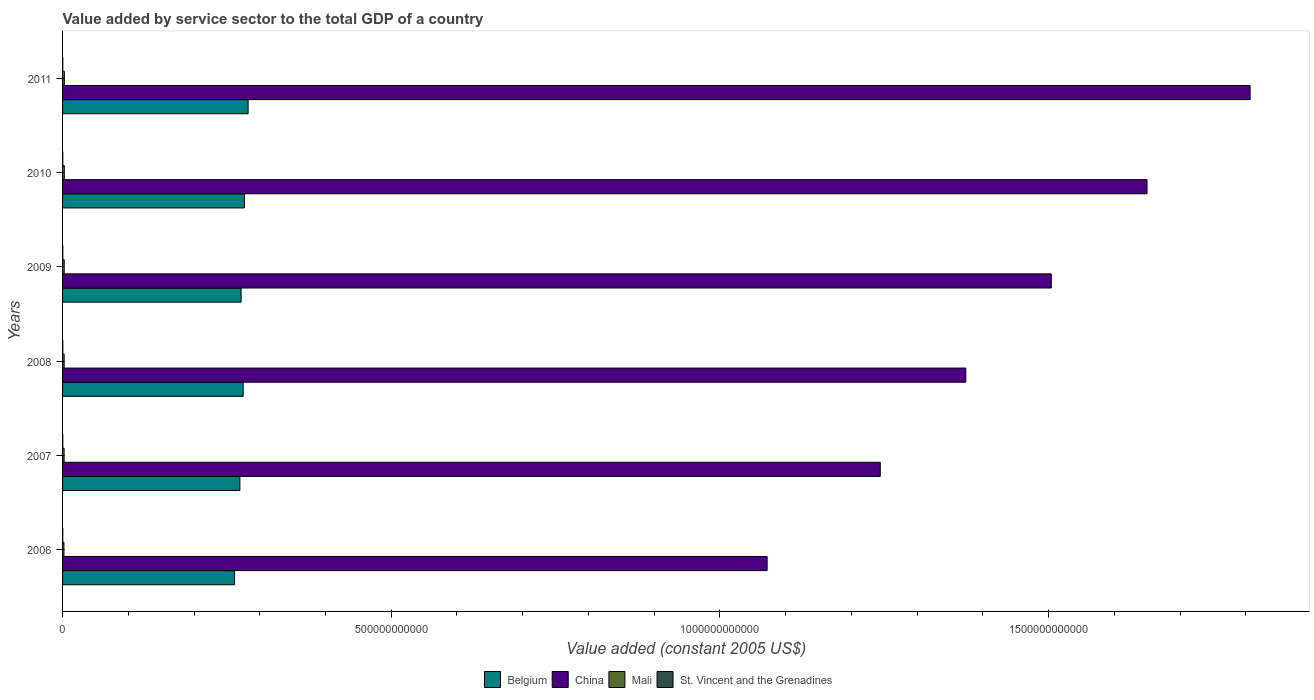How many bars are there on the 2nd tick from the top?
Keep it short and to the point. 4. What is the label of the 6th group of bars from the top?
Give a very brief answer. 2006. In how many cases, is the number of bars for a given year not equal to the number of legend labels?
Offer a terse response. 0. What is the value added by service sector in Mali in 2011?
Your answer should be compact. 2.73e+09. Across all years, what is the maximum value added by service sector in Belgium?
Ensure brevity in your answer.  2.82e+11. Across all years, what is the minimum value added by service sector in Mali?
Provide a succinct answer. 2.11e+09. In which year was the value added by service sector in St. Vincent and the Grenadines maximum?
Your response must be concise. 2008. In which year was the value added by service sector in Belgium minimum?
Your response must be concise. 2006. What is the total value added by service sector in St. Vincent and the Grenadines in the graph?
Your response must be concise. 2.31e+09. What is the difference between the value added by service sector in Mali in 2007 and that in 2011?
Provide a short and direct response. -3.99e+08. What is the difference between the value added by service sector in St. Vincent and the Grenadines in 2006 and the value added by service sector in Belgium in 2010?
Your response must be concise. -2.76e+11. What is the average value added by service sector in St. Vincent and the Grenadines per year?
Provide a succinct answer. 3.85e+08. In the year 2011, what is the difference between the value added by service sector in St. Vincent and the Grenadines and value added by service sector in Belgium?
Provide a short and direct response. -2.82e+11. In how many years, is the value added by service sector in Mali greater than 400000000000 US$?
Give a very brief answer. 0. What is the ratio of the value added by service sector in St. Vincent and the Grenadines in 2007 to that in 2011?
Your answer should be very brief. 1.01. Is the value added by service sector in China in 2007 less than that in 2009?
Keep it short and to the point. Yes. Is the difference between the value added by service sector in St. Vincent and the Grenadines in 2008 and 2010 greater than the difference between the value added by service sector in Belgium in 2008 and 2010?
Ensure brevity in your answer.  Yes. What is the difference between the highest and the second highest value added by service sector in Belgium?
Your answer should be very brief. 5.66e+09. What is the difference between the highest and the lowest value added by service sector in St. Vincent and the Grenadines?
Provide a succinct answer. 1.12e+07. In how many years, is the value added by service sector in China greater than the average value added by service sector in China taken over all years?
Make the answer very short. 3. Is the sum of the value added by service sector in Belgium in 2006 and 2011 greater than the maximum value added by service sector in St. Vincent and the Grenadines across all years?
Provide a short and direct response. Yes. Is it the case that in every year, the sum of the value added by service sector in China and value added by service sector in Mali is greater than the sum of value added by service sector in St. Vincent and the Grenadines and value added by service sector in Belgium?
Keep it short and to the point. Yes. What does the 4th bar from the top in 2010 represents?
Make the answer very short. Belgium. Is it the case that in every year, the sum of the value added by service sector in Mali and value added by service sector in Belgium is greater than the value added by service sector in China?
Ensure brevity in your answer.  No. Are all the bars in the graph horizontal?
Your response must be concise. Yes. What is the difference between two consecutive major ticks on the X-axis?
Your answer should be compact. 5.00e+11. Does the graph contain any zero values?
Your response must be concise. No. What is the title of the graph?
Your response must be concise. Value added by service sector to the total GDP of a country. What is the label or title of the X-axis?
Give a very brief answer. Value added (constant 2005 US$). What is the Value added (constant 2005 US$) of Belgium in 2006?
Your response must be concise. 2.62e+11. What is the Value added (constant 2005 US$) in China in 2006?
Provide a succinct answer. 1.07e+12. What is the Value added (constant 2005 US$) of Mali in 2006?
Your answer should be compact. 2.11e+09. What is the Value added (constant 2005 US$) of St. Vincent and the Grenadines in 2006?
Keep it short and to the point. 3.82e+08. What is the Value added (constant 2005 US$) in Belgium in 2007?
Offer a terse response. 2.70e+11. What is the Value added (constant 2005 US$) of China in 2007?
Provide a succinct answer. 1.24e+12. What is the Value added (constant 2005 US$) of Mali in 2007?
Give a very brief answer. 2.33e+09. What is the Value added (constant 2005 US$) in St. Vincent and the Grenadines in 2007?
Your answer should be very brief. 3.88e+08. What is the Value added (constant 2005 US$) in Belgium in 2008?
Give a very brief answer. 2.75e+11. What is the Value added (constant 2005 US$) of China in 2008?
Make the answer very short. 1.37e+12. What is the Value added (constant 2005 US$) of Mali in 2008?
Offer a terse response. 2.43e+09. What is the Value added (constant 2005 US$) of St. Vincent and the Grenadines in 2008?
Offer a terse response. 3.93e+08. What is the Value added (constant 2005 US$) in Belgium in 2009?
Give a very brief answer. 2.72e+11. What is the Value added (constant 2005 US$) of China in 2009?
Provide a succinct answer. 1.50e+12. What is the Value added (constant 2005 US$) of Mali in 2009?
Provide a short and direct response. 2.51e+09. What is the Value added (constant 2005 US$) in St. Vincent and the Grenadines in 2009?
Keep it short and to the point. 3.83e+08. What is the Value added (constant 2005 US$) in Belgium in 2010?
Your answer should be very brief. 2.77e+11. What is the Value added (constant 2005 US$) of China in 2010?
Offer a very short reply. 1.65e+12. What is the Value added (constant 2005 US$) in Mali in 2010?
Offer a terse response. 2.63e+09. What is the Value added (constant 2005 US$) in St. Vincent and the Grenadines in 2010?
Your answer should be very brief. 3.81e+08. What is the Value added (constant 2005 US$) in Belgium in 2011?
Give a very brief answer. 2.82e+11. What is the Value added (constant 2005 US$) in China in 2011?
Give a very brief answer. 1.81e+12. What is the Value added (constant 2005 US$) in Mali in 2011?
Provide a succinct answer. 2.73e+09. What is the Value added (constant 2005 US$) of St. Vincent and the Grenadines in 2011?
Ensure brevity in your answer.  3.84e+08. Across all years, what is the maximum Value added (constant 2005 US$) in Belgium?
Offer a terse response. 2.82e+11. Across all years, what is the maximum Value added (constant 2005 US$) of China?
Make the answer very short. 1.81e+12. Across all years, what is the maximum Value added (constant 2005 US$) in Mali?
Ensure brevity in your answer.  2.73e+09. Across all years, what is the maximum Value added (constant 2005 US$) of St. Vincent and the Grenadines?
Keep it short and to the point. 3.93e+08. Across all years, what is the minimum Value added (constant 2005 US$) of Belgium?
Provide a succinct answer. 2.62e+11. Across all years, what is the minimum Value added (constant 2005 US$) in China?
Offer a terse response. 1.07e+12. Across all years, what is the minimum Value added (constant 2005 US$) in Mali?
Keep it short and to the point. 2.11e+09. Across all years, what is the minimum Value added (constant 2005 US$) of St. Vincent and the Grenadines?
Make the answer very short. 3.81e+08. What is the total Value added (constant 2005 US$) of Belgium in the graph?
Offer a very short reply. 1.64e+12. What is the total Value added (constant 2005 US$) of China in the graph?
Give a very brief answer. 8.65e+12. What is the total Value added (constant 2005 US$) of Mali in the graph?
Offer a very short reply. 1.47e+1. What is the total Value added (constant 2005 US$) in St. Vincent and the Grenadines in the graph?
Your response must be concise. 2.31e+09. What is the difference between the Value added (constant 2005 US$) of Belgium in 2006 and that in 2007?
Offer a terse response. -8.08e+09. What is the difference between the Value added (constant 2005 US$) in China in 2006 and that in 2007?
Offer a very short reply. -1.72e+11. What is the difference between the Value added (constant 2005 US$) in Mali in 2006 and that in 2007?
Make the answer very short. -2.19e+08. What is the difference between the Value added (constant 2005 US$) of St. Vincent and the Grenadines in 2006 and that in 2007?
Offer a very short reply. -6.01e+06. What is the difference between the Value added (constant 2005 US$) of Belgium in 2006 and that in 2008?
Offer a terse response. -1.31e+1. What is the difference between the Value added (constant 2005 US$) in China in 2006 and that in 2008?
Make the answer very short. -3.02e+11. What is the difference between the Value added (constant 2005 US$) of Mali in 2006 and that in 2008?
Provide a short and direct response. -3.18e+08. What is the difference between the Value added (constant 2005 US$) in St. Vincent and the Grenadines in 2006 and that in 2008?
Your answer should be very brief. -1.02e+07. What is the difference between the Value added (constant 2005 US$) in Belgium in 2006 and that in 2009?
Your answer should be very brief. -9.95e+09. What is the difference between the Value added (constant 2005 US$) in China in 2006 and that in 2009?
Provide a succinct answer. -4.32e+11. What is the difference between the Value added (constant 2005 US$) in Mali in 2006 and that in 2009?
Your answer should be very brief. -4.04e+08. What is the difference between the Value added (constant 2005 US$) in St. Vincent and the Grenadines in 2006 and that in 2009?
Your response must be concise. -1.94e+05. What is the difference between the Value added (constant 2005 US$) of Belgium in 2006 and that in 2010?
Keep it short and to the point. -1.49e+1. What is the difference between the Value added (constant 2005 US$) of China in 2006 and that in 2010?
Give a very brief answer. -5.78e+11. What is the difference between the Value added (constant 2005 US$) in Mali in 2006 and that in 2010?
Offer a terse response. -5.18e+08. What is the difference between the Value added (constant 2005 US$) in St. Vincent and the Grenadines in 2006 and that in 2010?
Your answer should be very brief. 9.61e+05. What is the difference between the Value added (constant 2005 US$) of Belgium in 2006 and that in 2011?
Provide a short and direct response. -2.06e+1. What is the difference between the Value added (constant 2005 US$) in China in 2006 and that in 2011?
Offer a terse response. -7.35e+11. What is the difference between the Value added (constant 2005 US$) in Mali in 2006 and that in 2011?
Give a very brief answer. -6.18e+08. What is the difference between the Value added (constant 2005 US$) of St. Vincent and the Grenadines in 2006 and that in 2011?
Offer a very short reply. -1.56e+06. What is the difference between the Value added (constant 2005 US$) in Belgium in 2007 and that in 2008?
Your answer should be very brief. -5.02e+09. What is the difference between the Value added (constant 2005 US$) of China in 2007 and that in 2008?
Make the answer very short. -1.30e+11. What is the difference between the Value added (constant 2005 US$) in Mali in 2007 and that in 2008?
Provide a short and direct response. -9.94e+07. What is the difference between the Value added (constant 2005 US$) of St. Vincent and the Grenadines in 2007 and that in 2008?
Make the answer very short. -4.21e+06. What is the difference between the Value added (constant 2005 US$) in Belgium in 2007 and that in 2009?
Your response must be concise. -1.87e+09. What is the difference between the Value added (constant 2005 US$) in China in 2007 and that in 2009?
Give a very brief answer. -2.60e+11. What is the difference between the Value added (constant 2005 US$) in Mali in 2007 and that in 2009?
Your response must be concise. -1.85e+08. What is the difference between the Value added (constant 2005 US$) in St. Vincent and the Grenadines in 2007 and that in 2009?
Your answer should be compact. 5.81e+06. What is the difference between the Value added (constant 2005 US$) of Belgium in 2007 and that in 2010?
Provide a short and direct response. -6.84e+09. What is the difference between the Value added (constant 2005 US$) of China in 2007 and that in 2010?
Keep it short and to the point. -4.06e+11. What is the difference between the Value added (constant 2005 US$) in Mali in 2007 and that in 2010?
Provide a succinct answer. -2.99e+08. What is the difference between the Value added (constant 2005 US$) in St. Vincent and the Grenadines in 2007 and that in 2010?
Your response must be concise. 6.97e+06. What is the difference between the Value added (constant 2005 US$) in Belgium in 2007 and that in 2011?
Your answer should be compact. -1.25e+1. What is the difference between the Value added (constant 2005 US$) in China in 2007 and that in 2011?
Your answer should be compact. -5.63e+11. What is the difference between the Value added (constant 2005 US$) in Mali in 2007 and that in 2011?
Offer a very short reply. -3.99e+08. What is the difference between the Value added (constant 2005 US$) of St. Vincent and the Grenadines in 2007 and that in 2011?
Make the answer very short. 4.45e+06. What is the difference between the Value added (constant 2005 US$) in Belgium in 2008 and that in 2009?
Offer a very short reply. 3.15e+09. What is the difference between the Value added (constant 2005 US$) in China in 2008 and that in 2009?
Your response must be concise. -1.30e+11. What is the difference between the Value added (constant 2005 US$) in Mali in 2008 and that in 2009?
Ensure brevity in your answer.  -8.58e+07. What is the difference between the Value added (constant 2005 US$) in St. Vincent and the Grenadines in 2008 and that in 2009?
Your answer should be compact. 1.00e+07. What is the difference between the Value added (constant 2005 US$) in Belgium in 2008 and that in 2010?
Your answer should be compact. -1.81e+09. What is the difference between the Value added (constant 2005 US$) of China in 2008 and that in 2010?
Your answer should be compact. -2.76e+11. What is the difference between the Value added (constant 2005 US$) in Mali in 2008 and that in 2010?
Keep it short and to the point. -2.00e+08. What is the difference between the Value added (constant 2005 US$) of St. Vincent and the Grenadines in 2008 and that in 2010?
Provide a short and direct response. 1.12e+07. What is the difference between the Value added (constant 2005 US$) of Belgium in 2008 and that in 2011?
Provide a short and direct response. -7.47e+09. What is the difference between the Value added (constant 2005 US$) in China in 2008 and that in 2011?
Your answer should be compact. -4.33e+11. What is the difference between the Value added (constant 2005 US$) in Mali in 2008 and that in 2011?
Keep it short and to the point. -3.00e+08. What is the difference between the Value added (constant 2005 US$) of St. Vincent and the Grenadines in 2008 and that in 2011?
Your response must be concise. 8.65e+06. What is the difference between the Value added (constant 2005 US$) in Belgium in 2009 and that in 2010?
Your answer should be compact. -4.96e+09. What is the difference between the Value added (constant 2005 US$) of China in 2009 and that in 2010?
Offer a terse response. -1.46e+11. What is the difference between the Value added (constant 2005 US$) of Mali in 2009 and that in 2010?
Make the answer very short. -1.14e+08. What is the difference between the Value added (constant 2005 US$) in St. Vincent and the Grenadines in 2009 and that in 2010?
Your response must be concise. 1.16e+06. What is the difference between the Value added (constant 2005 US$) of Belgium in 2009 and that in 2011?
Keep it short and to the point. -1.06e+1. What is the difference between the Value added (constant 2005 US$) of China in 2009 and that in 2011?
Offer a very short reply. -3.02e+11. What is the difference between the Value added (constant 2005 US$) in Mali in 2009 and that in 2011?
Provide a succinct answer. -2.14e+08. What is the difference between the Value added (constant 2005 US$) of St. Vincent and the Grenadines in 2009 and that in 2011?
Provide a short and direct response. -1.37e+06. What is the difference between the Value added (constant 2005 US$) in Belgium in 2010 and that in 2011?
Offer a very short reply. -5.66e+09. What is the difference between the Value added (constant 2005 US$) in China in 2010 and that in 2011?
Offer a terse response. -1.57e+11. What is the difference between the Value added (constant 2005 US$) in Mali in 2010 and that in 2011?
Offer a terse response. -1.00e+08. What is the difference between the Value added (constant 2005 US$) in St. Vincent and the Grenadines in 2010 and that in 2011?
Your answer should be very brief. -2.52e+06. What is the difference between the Value added (constant 2005 US$) of Belgium in 2006 and the Value added (constant 2005 US$) of China in 2007?
Your answer should be compact. -9.82e+11. What is the difference between the Value added (constant 2005 US$) in Belgium in 2006 and the Value added (constant 2005 US$) in Mali in 2007?
Keep it short and to the point. 2.59e+11. What is the difference between the Value added (constant 2005 US$) in Belgium in 2006 and the Value added (constant 2005 US$) in St. Vincent and the Grenadines in 2007?
Keep it short and to the point. 2.61e+11. What is the difference between the Value added (constant 2005 US$) in China in 2006 and the Value added (constant 2005 US$) in Mali in 2007?
Give a very brief answer. 1.07e+12. What is the difference between the Value added (constant 2005 US$) in China in 2006 and the Value added (constant 2005 US$) in St. Vincent and the Grenadines in 2007?
Keep it short and to the point. 1.07e+12. What is the difference between the Value added (constant 2005 US$) of Mali in 2006 and the Value added (constant 2005 US$) of St. Vincent and the Grenadines in 2007?
Offer a terse response. 1.72e+09. What is the difference between the Value added (constant 2005 US$) of Belgium in 2006 and the Value added (constant 2005 US$) of China in 2008?
Give a very brief answer. -1.11e+12. What is the difference between the Value added (constant 2005 US$) of Belgium in 2006 and the Value added (constant 2005 US$) of Mali in 2008?
Your answer should be very brief. 2.59e+11. What is the difference between the Value added (constant 2005 US$) in Belgium in 2006 and the Value added (constant 2005 US$) in St. Vincent and the Grenadines in 2008?
Your answer should be compact. 2.61e+11. What is the difference between the Value added (constant 2005 US$) in China in 2006 and the Value added (constant 2005 US$) in Mali in 2008?
Provide a succinct answer. 1.07e+12. What is the difference between the Value added (constant 2005 US$) in China in 2006 and the Value added (constant 2005 US$) in St. Vincent and the Grenadines in 2008?
Keep it short and to the point. 1.07e+12. What is the difference between the Value added (constant 2005 US$) of Mali in 2006 and the Value added (constant 2005 US$) of St. Vincent and the Grenadines in 2008?
Provide a succinct answer. 1.72e+09. What is the difference between the Value added (constant 2005 US$) of Belgium in 2006 and the Value added (constant 2005 US$) of China in 2009?
Ensure brevity in your answer.  -1.24e+12. What is the difference between the Value added (constant 2005 US$) of Belgium in 2006 and the Value added (constant 2005 US$) of Mali in 2009?
Provide a succinct answer. 2.59e+11. What is the difference between the Value added (constant 2005 US$) in Belgium in 2006 and the Value added (constant 2005 US$) in St. Vincent and the Grenadines in 2009?
Your answer should be compact. 2.61e+11. What is the difference between the Value added (constant 2005 US$) in China in 2006 and the Value added (constant 2005 US$) in Mali in 2009?
Your answer should be compact. 1.07e+12. What is the difference between the Value added (constant 2005 US$) in China in 2006 and the Value added (constant 2005 US$) in St. Vincent and the Grenadines in 2009?
Your response must be concise. 1.07e+12. What is the difference between the Value added (constant 2005 US$) of Mali in 2006 and the Value added (constant 2005 US$) of St. Vincent and the Grenadines in 2009?
Give a very brief answer. 1.73e+09. What is the difference between the Value added (constant 2005 US$) in Belgium in 2006 and the Value added (constant 2005 US$) in China in 2010?
Keep it short and to the point. -1.39e+12. What is the difference between the Value added (constant 2005 US$) in Belgium in 2006 and the Value added (constant 2005 US$) in Mali in 2010?
Offer a very short reply. 2.59e+11. What is the difference between the Value added (constant 2005 US$) of Belgium in 2006 and the Value added (constant 2005 US$) of St. Vincent and the Grenadines in 2010?
Ensure brevity in your answer.  2.61e+11. What is the difference between the Value added (constant 2005 US$) of China in 2006 and the Value added (constant 2005 US$) of Mali in 2010?
Provide a succinct answer. 1.07e+12. What is the difference between the Value added (constant 2005 US$) of China in 2006 and the Value added (constant 2005 US$) of St. Vincent and the Grenadines in 2010?
Provide a succinct answer. 1.07e+12. What is the difference between the Value added (constant 2005 US$) of Mali in 2006 and the Value added (constant 2005 US$) of St. Vincent and the Grenadines in 2010?
Your response must be concise. 1.73e+09. What is the difference between the Value added (constant 2005 US$) of Belgium in 2006 and the Value added (constant 2005 US$) of China in 2011?
Give a very brief answer. -1.54e+12. What is the difference between the Value added (constant 2005 US$) of Belgium in 2006 and the Value added (constant 2005 US$) of Mali in 2011?
Make the answer very short. 2.59e+11. What is the difference between the Value added (constant 2005 US$) in Belgium in 2006 and the Value added (constant 2005 US$) in St. Vincent and the Grenadines in 2011?
Offer a terse response. 2.61e+11. What is the difference between the Value added (constant 2005 US$) of China in 2006 and the Value added (constant 2005 US$) of Mali in 2011?
Provide a short and direct response. 1.07e+12. What is the difference between the Value added (constant 2005 US$) of China in 2006 and the Value added (constant 2005 US$) of St. Vincent and the Grenadines in 2011?
Offer a very short reply. 1.07e+12. What is the difference between the Value added (constant 2005 US$) in Mali in 2006 and the Value added (constant 2005 US$) in St. Vincent and the Grenadines in 2011?
Your response must be concise. 1.72e+09. What is the difference between the Value added (constant 2005 US$) of Belgium in 2007 and the Value added (constant 2005 US$) of China in 2008?
Offer a very short reply. -1.10e+12. What is the difference between the Value added (constant 2005 US$) in Belgium in 2007 and the Value added (constant 2005 US$) in Mali in 2008?
Your answer should be compact. 2.67e+11. What is the difference between the Value added (constant 2005 US$) in Belgium in 2007 and the Value added (constant 2005 US$) in St. Vincent and the Grenadines in 2008?
Ensure brevity in your answer.  2.69e+11. What is the difference between the Value added (constant 2005 US$) in China in 2007 and the Value added (constant 2005 US$) in Mali in 2008?
Your response must be concise. 1.24e+12. What is the difference between the Value added (constant 2005 US$) in China in 2007 and the Value added (constant 2005 US$) in St. Vincent and the Grenadines in 2008?
Ensure brevity in your answer.  1.24e+12. What is the difference between the Value added (constant 2005 US$) of Mali in 2007 and the Value added (constant 2005 US$) of St. Vincent and the Grenadines in 2008?
Provide a succinct answer. 1.93e+09. What is the difference between the Value added (constant 2005 US$) in Belgium in 2007 and the Value added (constant 2005 US$) in China in 2009?
Your response must be concise. -1.23e+12. What is the difference between the Value added (constant 2005 US$) of Belgium in 2007 and the Value added (constant 2005 US$) of Mali in 2009?
Your answer should be compact. 2.67e+11. What is the difference between the Value added (constant 2005 US$) in Belgium in 2007 and the Value added (constant 2005 US$) in St. Vincent and the Grenadines in 2009?
Your response must be concise. 2.69e+11. What is the difference between the Value added (constant 2005 US$) in China in 2007 and the Value added (constant 2005 US$) in Mali in 2009?
Make the answer very short. 1.24e+12. What is the difference between the Value added (constant 2005 US$) in China in 2007 and the Value added (constant 2005 US$) in St. Vincent and the Grenadines in 2009?
Your answer should be compact. 1.24e+12. What is the difference between the Value added (constant 2005 US$) in Mali in 2007 and the Value added (constant 2005 US$) in St. Vincent and the Grenadines in 2009?
Provide a succinct answer. 1.94e+09. What is the difference between the Value added (constant 2005 US$) of Belgium in 2007 and the Value added (constant 2005 US$) of China in 2010?
Your response must be concise. -1.38e+12. What is the difference between the Value added (constant 2005 US$) in Belgium in 2007 and the Value added (constant 2005 US$) in Mali in 2010?
Provide a succinct answer. 2.67e+11. What is the difference between the Value added (constant 2005 US$) in Belgium in 2007 and the Value added (constant 2005 US$) in St. Vincent and the Grenadines in 2010?
Give a very brief answer. 2.69e+11. What is the difference between the Value added (constant 2005 US$) in China in 2007 and the Value added (constant 2005 US$) in Mali in 2010?
Keep it short and to the point. 1.24e+12. What is the difference between the Value added (constant 2005 US$) of China in 2007 and the Value added (constant 2005 US$) of St. Vincent and the Grenadines in 2010?
Your answer should be very brief. 1.24e+12. What is the difference between the Value added (constant 2005 US$) in Mali in 2007 and the Value added (constant 2005 US$) in St. Vincent and the Grenadines in 2010?
Provide a succinct answer. 1.95e+09. What is the difference between the Value added (constant 2005 US$) of Belgium in 2007 and the Value added (constant 2005 US$) of China in 2011?
Your answer should be very brief. -1.54e+12. What is the difference between the Value added (constant 2005 US$) in Belgium in 2007 and the Value added (constant 2005 US$) in Mali in 2011?
Offer a terse response. 2.67e+11. What is the difference between the Value added (constant 2005 US$) in Belgium in 2007 and the Value added (constant 2005 US$) in St. Vincent and the Grenadines in 2011?
Ensure brevity in your answer.  2.69e+11. What is the difference between the Value added (constant 2005 US$) of China in 2007 and the Value added (constant 2005 US$) of Mali in 2011?
Your answer should be very brief. 1.24e+12. What is the difference between the Value added (constant 2005 US$) in China in 2007 and the Value added (constant 2005 US$) in St. Vincent and the Grenadines in 2011?
Your response must be concise. 1.24e+12. What is the difference between the Value added (constant 2005 US$) of Mali in 2007 and the Value added (constant 2005 US$) of St. Vincent and the Grenadines in 2011?
Your answer should be very brief. 1.94e+09. What is the difference between the Value added (constant 2005 US$) in Belgium in 2008 and the Value added (constant 2005 US$) in China in 2009?
Your answer should be compact. -1.23e+12. What is the difference between the Value added (constant 2005 US$) in Belgium in 2008 and the Value added (constant 2005 US$) in Mali in 2009?
Your answer should be very brief. 2.72e+11. What is the difference between the Value added (constant 2005 US$) of Belgium in 2008 and the Value added (constant 2005 US$) of St. Vincent and the Grenadines in 2009?
Your response must be concise. 2.74e+11. What is the difference between the Value added (constant 2005 US$) in China in 2008 and the Value added (constant 2005 US$) in Mali in 2009?
Offer a terse response. 1.37e+12. What is the difference between the Value added (constant 2005 US$) of China in 2008 and the Value added (constant 2005 US$) of St. Vincent and the Grenadines in 2009?
Provide a short and direct response. 1.37e+12. What is the difference between the Value added (constant 2005 US$) in Mali in 2008 and the Value added (constant 2005 US$) in St. Vincent and the Grenadines in 2009?
Your answer should be compact. 2.04e+09. What is the difference between the Value added (constant 2005 US$) of Belgium in 2008 and the Value added (constant 2005 US$) of China in 2010?
Keep it short and to the point. -1.38e+12. What is the difference between the Value added (constant 2005 US$) in Belgium in 2008 and the Value added (constant 2005 US$) in Mali in 2010?
Give a very brief answer. 2.72e+11. What is the difference between the Value added (constant 2005 US$) of Belgium in 2008 and the Value added (constant 2005 US$) of St. Vincent and the Grenadines in 2010?
Provide a short and direct response. 2.74e+11. What is the difference between the Value added (constant 2005 US$) in China in 2008 and the Value added (constant 2005 US$) in Mali in 2010?
Offer a very short reply. 1.37e+12. What is the difference between the Value added (constant 2005 US$) in China in 2008 and the Value added (constant 2005 US$) in St. Vincent and the Grenadines in 2010?
Your answer should be compact. 1.37e+12. What is the difference between the Value added (constant 2005 US$) of Mali in 2008 and the Value added (constant 2005 US$) of St. Vincent and the Grenadines in 2010?
Your response must be concise. 2.04e+09. What is the difference between the Value added (constant 2005 US$) of Belgium in 2008 and the Value added (constant 2005 US$) of China in 2011?
Offer a terse response. -1.53e+12. What is the difference between the Value added (constant 2005 US$) of Belgium in 2008 and the Value added (constant 2005 US$) of Mali in 2011?
Your response must be concise. 2.72e+11. What is the difference between the Value added (constant 2005 US$) of Belgium in 2008 and the Value added (constant 2005 US$) of St. Vincent and the Grenadines in 2011?
Provide a succinct answer. 2.74e+11. What is the difference between the Value added (constant 2005 US$) of China in 2008 and the Value added (constant 2005 US$) of Mali in 2011?
Your response must be concise. 1.37e+12. What is the difference between the Value added (constant 2005 US$) of China in 2008 and the Value added (constant 2005 US$) of St. Vincent and the Grenadines in 2011?
Keep it short and to the point. 1.37e+12. What is the difference between the Value added (constant 2005 US$) in Mali in 2008 and the Value added (constant 2005 US$) in St. Vincent and the Grenadines in 2011?
Your answer should be compact. 2.04e+09. What is the difference between the Value added (constant 2005 US$) of Belgium in 2009 and the Value added (constant 2005 US$) of China in 2010?
Make the answer very short. -1.38e+12. What is the difference between the Value added (constant 2005 US$) of Belgium in 2009 and the Value added (constant 2005 US$) of Mali in 2010?
Keep it short and to the point. 2.69e+11. What is the difference between the Value added (constant 2005 US$) in Belgium in 2009 and the Value added (constant 2005 US$) in St. Vincent and the Grenadines in 2010?
Provide a succinct answer. 2.71e+11. What is the difference between the Value added (constant 2005 US$) in China in 2009 and the Value added (constant 2005 US$) in Mali in 2010?
Ensure brevity in your answer.  1.50e+12. What is the difference between the Value added (constant 2005 US$) in China in 2009 and the Value added (constant 2005 US$) in St. Vincent and the Grenadines in 2010?
Offer a very short reply. 1.50e+12. What is the difference between the Value added (constant 2005 US$) of Mali in 2009 and the Value added (constant 2005 US$) of St. Vincent and the Grenadines in 2010?
Your answer should be very brief. 2.13e+09. What is the difference between the Value added (constant 2005 US$) of Belgium in 2009 and the Value added (constant 2005 US$) of China in 2011?
Provide a succinct answer. -1.54e+12. What is the difference between the Value added (constant 2005 US$) of Belgium in 2009 and the Value added (constant 2005 US$) of Mali in 2011?
Offer a terse response. 2.69e+11. What is the difference between the Value added (constant 2005 US$) in Belgium in 2009 and the Value added (constant 2005 US$) in St. Vincent and the Grenadines in 2011?
Ensure brevity in your answer.  2.71e+11. What is the difference between the Value added (constant 2005 US$) of China in 2009 and the Value added (constant 2005 US$) of Mali in 2011?
Keep it short and to the point. 1.50e+12. What is the difference between the Value added (constant 2005 US$) of China in 2009 and the Value added (constant 2005 US$) of St. Vincent and the Grenadines in 2011?
Offer a very short reply. 1.50e+12. What is the difference between the Value added (constant 2005 US$) of Mali in 2009 and the Value added (constant 2005 US$) of St. Vincent and the Grenadines in 2011?
Offer a terse response. 2.13e+09. What is the difference between the Value added (constant 2005 US$) in Belgium in 2010 and the Value added (constant 2005 US$) in China in 2011?
Offer a very short reply. -1.53e+12. What is the difference between the Value added (constant 2005 US$) of Belgium in 2010 and the Value added (constant 2005 US$) of Mali in 2011?
Provide a succinct answer. 2.74e+11. What is the difference between the Value added (constant 2005 US$) of Belgium in 2010 and the Value added (constant 2005 US$) of St. Vincent and the Grenadines in 2011?
Provide a short and direct response. 2.76e+11. What is the difference between the Value added (constant 2005 US$) of China in 2010 and the Value added (constant 2005 US$) of Mali in 2011?
Ensure brevity in your answer.  1.65e+12. What is the difference between the Value added (constant 2005 US$) of China in 2010 and the Value added (constant 2005 US$) of St. Vincent and the Grenadines in 2011?
Provide a short and direct response. 1.65e+12. What is the difference between the Value added (constant 2005 US$) of Mali in 2010 and the Value added (constant 2005 US$) of St. Vincent and the Grenadines in 2011?
Your response must be concise. 2.24e+09. What is the average Value added (constant 2005 US$) in Belgium per year?
Provide a short and direct response. 2.73e+11. What is the average Value added (constant 2005 US$) of China per year?
Ensure brevity in your answer.  1.44e+12. What is the average Value added (constant 2005 US$) in Mali per year?
Your answer should be compact. 2.45e+09. What is the average Value added (constant 2005 US$) of St. Vincent and the Grenadines per year?
Offer a very short reply. 3.85e+08. In the year 2006, what is the difference between the Value added (constant 2005 US$) of Belgium and Value added (constant 2005 US$) of China?
Your answer should be compact. -8.10e+11. In the year 2006, what is the difference between the Value added (constant 2005 US$) of Belgium and Value added (constant 2005 US$) of Mali?
Offer a terse response. 2.60e+11. In the year 2006, what is the difference between the Value added (constant 2005 US$) of Belgium and Value added (constant 2005 US$) of St. Vincent and the Grenadines?
Your answer should be compact. 2.61e+11. In the year 2006, what is the difference between the Value added (constant 2005 US$) of China and Value added (constant 2005 US$) of Mali?
Your answer should be compact. 1.07e+12. In the year 2006, what is the difference between the Value added (constant 2005 US$) in China and Value added (constant 2005 US$) in St. Vincent and the Grenadines?
Offer a terse response. 1.07e+12. In the year 2006, what is the difference between the Value added (constant 2005 US$) of Mali and Value added (constant 2005 US$) of St. Vincent and the Grenadines?
Give a very brief answer. 1.73e+09. In the year 2007, what is the difference between the Value added (constant 2005 US$) in Belgium and Value added (constant 2005 US$) in China?
Ensure brevity in your answer.  -9.74e+11. In the year 2007, what is the difference between the Value added (constant 2005 US$) in Belgium and Value added (constant 2005 US$) in Mali?
Offer a very short reply. 2.67e+11. In the year 2007, what is the difference between the Value added (constant 2005 US$) of Belgium and Value added (constant 2005 US$) of St. Vincent and the Grenadines?
Give a very brief answer. 2.69e+11. In the year 2007, what is the difference between the Value added (constant 2005 US$) in China and Value added (constant 2005 US$) in Mali?
Provide a succinct answer. 1.24e+12. In the year 2007, what is the difference between the Value added (constant 2005 US$) in China and Value added (constant 2005 US$) in St. Vincent and the Grenadines?
Offer a terse response. 1.24e+12. In the year 2007, what is the difference between the Value added (constant 2005 US$) of Mali and Value added (constant 2005 US$) of St. Vincent and the Grenadines?
Provide a short and direct response. 1.94e+09. In the year 2008, what is the difference between the Value added (constant 2005 US$) of Belgium and Value added (constant 2005 US$) of China?
Make the answer very short. -1.10e+12. In the year 2008, what is the difference between the Value added (constant 2005 US$) in Belgium and Value added (constant 2005 US$) in Mali?
Ensure brevity in your answer.  2.72e+11. In the year 2008, what is the difference between the Value added (constant 2005 US$) of Belgium and Value added (constant 2005 US$) of St. Vincent and the Grenadines?
Your response must be concise. 2.74e+11. In the year 2008, what is the difference between the Value added (constant 2005 US$) in China and Value added (constant 2005 US$) in Mali?
Offer a terse response. 1.37e+12. In the year 2008, what is the difference between the Value added (constant 2005 US$) in China and Value added (constant 2005 US$) in St. Vincent and the Grenadines?
Make the answer very short. 1.37e+12. In the year 2008, what is the difference between the Value added (constant 2005 US$) in Mali and Value added (constant 2005 US$) in St. Vincent and the Grenadines?
Your response must be concise. 2.03e+09. In the year 2009, what is the difference between the Value added (constant 2005 US$) in Belgium and Value added (constant 2005 US$) in China?
Your answer should be very brief. -1.23e+12. In the year 2009, what is the difference between the Value added (constant 2005 US$) in Belgium and Value added (constant 2005 US$) in Mali?
Provide a short and direct response. 2.69e+11. In the year 2009, what is the difference between the Value added (constant 2005 US$) in Belgium and Value added (constant 2005 US$) in St. Vincent and the Grenadines?
Keep it short and to the point. 2.71e+11. In the year 2009, what is the difference between the Value added (constant 2005 US$) of China and Value added (constant 2005 US$) of Mali?
Provide a short and direct response. 1.50e+12. In the year 2009, what is the difference between the Value added (constant 2005 US$) of China and Value added (constant 2005 US$) of St. Vincent and the Grenadines?
Your answer should be very brief. 1.50e+12. In the year 2009, what is the difference between the Value added (constant 2005 US$) in Mali and Value added (constant 2005 US$) in St. Vincent and the Grenadines?
Provide a succinct answer. 2.13e+09. In the year 2010, what is the difference between the Value added (constant 2005 US$) in Belgium and Value added (constant 2005 US$) in China?
Offer a very short reply. -1.37e+12. In the year 2010, what is the difference between the Value added (constant 2005 US$) in Belgium and Value added (constant 2005 US$) in Mali?
Your response must be concise. 2.74e+11. In the year 2010, what is the difference between the Value added (constant 2005 US$) of Belgium and Value added (constant 2005 US$) of St. Vincent and the Grenadines?
Keep it short and to the point. 2.76e+11. In the year 2010, what is the difference between the Value added (constant 2005 US$) of China and Value added (constant 2005 US$) of Mali?
Provide a succinct answer. 1.65e+12. In the year 2010, what is the difference between the Value added (constant 2005 US$) in China and Value added (constant 2005 US$) in St. Vincent and the Grenadines?
Provide a short and direct response. 1.65e+12. In the year 2010, what is the difference between the Value added (constant 2005 US$) of Mali and Value added (constant 2005 US$) of St. Vincent and the Grenadines?
Provide a short and direct response. 2.24e+09. In the year 2011, what is the difference between the Value added (constant 2005 US$) in Belgium and Value added (constant 2005 US$) in China?
Provide a short and direct response. -1.52e+12. In the year 2011, what is the difference between the Value added (constant 2005 US$) of Belgium and Value added (constant 2005 US$) of Mali?
Keep it short and to the point. 2.80e+11. In the year 2011, what is the difference between the Value added (constant 2005 US$) of Belgium and Value added (constant 2005 US$) of St. Vincent and the Grenadines?
Your response must be concise. 2.82e+11. In the year 2011, what is the difference between the Value added (constant 2005 US$) in China and Value added (constant 2005 US$) in Mali?
Ensure brevity in your answer.  1.80e+12. In the year 2011, what is the difference between the Value added (constant 2005 US$) in China and Value added (constant 2005 US$) in St. Vincent and the Grenadines?
Ensure brevity in your answer.  1.81e+12. In the year 2011, what is the difference between the Value added (constant 2005 US$) of Mali and Value added (constant 2005 US$) of St. Vincent and the Grenadines?
Provide a succinct answer. 2.34e+09. What is the ratio of the Value added (constant 2005 US$) in Belgium in 2006 to that in 2007?
Give a very brief answer. 0.97. What is the ratio of the Value added (constant 2005 US$) of China in 2006 to that in 2007?
Give a very brief answer. 0.86. What is the ratio of the Value added (constant 2005 US$) of Mali in 2006 to that in 2007?
Provide a succinct answer. 0.91. What is the ratio of the Value added (constant 2005 US$) of St. Vincent and the Grenadines in 2006 to that in 2007?
Ensure brevity in your answer.  0.98. What is the ratio of the Value added (constant 2005 US$) of Belgium in 2006 to that in 2008?
Provide a succinct answer. 0.95. What is the ratio of the Value added (constant 2005 US$) of China in 2006 to that in 2008?
Ensure brevity in your answer.  0.78. What is the ratio of the Value added (constant 2005 US$) of Mali in 2006 to that in 2008?
Keep it short and to the point. 0.87. What is the ratio of the Value added (constant 2005 US$) in Belgium in 2006 to that in 2009?
Offer a terse response. 0.96. What is the ratio of the Value added (constant 2005 US$) in China in 2006 to that in 2009?
Offer a very short reply. 0.71. What is the ratio of the Value added (constant 2005 US$) in Mali in 2006 to that in 2009?
Keep it short and to the point. 0.84. What is the ratio of the Value added (constant 2005 US$) in Belgium in 2006 to that in 2010?
Give a very brief answer. 0.95. What is the ratio of the Value added (constant 2005 US$) of China in 2006 to that in 2010?
Ensure brevity in your answer.  0.65. What is the ratio of the Value added (constant 2005 US$) in Mali in 2006 to that in 2010?
Give a very brief answer. 0.8. What is the ratio of the Value added (constant 2005 US$) of Belgium in 2006 to that in 2011?
Your answer should be compact. 0.93. What is the ratio of the Value added (constant 2005 US$) in China in 2006 to that in 2011?
Your response must be concise. 0.59. What is the ratio of the Value added (constant 2005 US$) of Mali in 2006 to that in 2011?
Offer a terse response. 0.77. What is the ratio of the Value added (constant 2005 US$) of Belgium in 2007 to that in 2008?
Offer a very short reply. 0.98. What is the ratio of the Value added (constant 2005 US$) in China in 2007 to that in 2008?
Make the answer very short. 0.91. What is the ratio of the Value added (constant 2005 US$) in Mali in 2007 to that in 2008?
Your response must be concise. 0.96. What is the ratio of the Value added (constant 2005 US$) in St. Vincent and the Grenadines in 2007 to that in 2008?
Provide a short and direct response. 0.99. What is the ratio of the Value added (constant 2005 US$) of Belgium in 2007 to that in 2009?
Give a very brief answer. 0.99. What is the ratio of the Value added (constant 2005 US$) of China in 2007 to that in 2009?
Offer a very short reply. 0.83. What is the ratio of the Value added (constant 2005 US$) in Mali in 2007 to that in 2009?
Give a very brief answer. 0.93. What is the ratio of the Value added (constant 2005 US$) in St. Vincent and the Grenadines in 2007 to that in 2009?
Ensure brevity in your answer.  1.02. What is the ratio of the Value added (constant 2005 US$) of Belgium in 2007 to that in 2010?
Make the answer very short. 0.98. What is the ratio of the Value added (constant 2005 US$) in China in 2007 to that in 2010?
Your answer should be compact. 0.75. What is the ratio of the Value added (constant 2005 US$) of Mali in 2007 to that in 2010?
Keep it short and to the point. 0.89. What is the ratio of the Value added (constant 2005 US$) of St. Vincent and the Grenadines in 2007 to that in 2010?
Offer a very short reply. 1.02. What is the ratio of the Value added (constant 2005 US$) in Belgium in 2007 to that in 2011?
Keep it short and to the point. 0.96. What is the ratio of the Value added (constant 2005 US$) in China in 2007 to that in 2011?
Give a very brief answer. 0.69. What is the ratio of the Value added (constant 2005 US$) in Mali in 2007 to that in 2011?
Offer a terse response. 0.85. What is the ratio of the Value added (constant 2005 US$) of St. Vincent and the Grenadines in 2007 to that in 2011?
Provide a short and direct response. 1.01. What is the ratio of the Value added (constant 2005 US$) of Belgium in 2008 to that in 2009?
Give a very brief answer. 1.01. What is the ratio of the Value added (constant 2005 US$) of China in 2008 to that in 2009?
Offer a terse response. 0.91. What is the ratio of the Value added (constant 2005 US$) in Mali in 2008 to that in 2009?
Your answer should be very brief. 0.97. What is the ratio of the Value added (constant 2005 US$) in St. Vincent and the Grenadines in 2008 to that in 2009?
Ensure brevity in your answer.  1.03. What is the ratio of the Value added (constant 2005 US$) in China in 2008 to that in 2010?
Keep it short and to the point. 0.83. What is the ratio of the Value added (constant 2005 US$) in Mali in 2008 to that in 2010?
Ensure brevity in your answer.  0.92. What is the ratio of the Value added (constant 2005 US$) of St. Vincent and the Grenadines in 2008 to that in 2010?
Offer a terse response. 1.03. What is the ratio of the Value added (constant 2005 US$) in Belgium in 2008 to that in 2011?
Keep it short and to the point. 0.97. What is the ratio of the Value added (constant 2005 US$) of China in 2008 to that in 2011?
Your answer should be very brief. 0.76. What is the ratio of the Value added (constant 2005 US$) in Mali in 2008 to that in 2011?
Ensure brevity in your answer.  0.89. What is the ratio of the Value added (constant 2005 US$) in St. Vincent and the Grenadines in 2008 to that in 2011?
Give a very brief answer. 1.02. What is the ratio of the Value added (constant 2005 US$) of Belgium in 2009 to that in 2010?
Your answer should be very brief. 0.98. What is the ratio of the Value added (constant 2005 US$) in China in 2009 to that in 2010?
Keep it short and to the point. 0.91. What is the ratio of the Value added (constant 2005 US$) in Mali in 2009 to that in 2010?
Offer a very short reply. 0.96. What is the ratio of the Value added (constant 2005 US$) in St. Vincent and the Grenadines in 2009 to that in 2010?
Keep it short and to the point. 1. What is the ratio of the Value added (constant 2005 US$) in Belgium in 2009 to that in 2011?
Provide a succinct answer. 0.96. What is the ratio of the Value added (constant 2005 US$) in China in 2009 to that in 2011?
Offer a terse response. 0.83. What is the ratio of the Value added (constant 2005 US$) in Mali in 2009 to that in 2011?
Your response must be concise. 0.92. What is the ratio of the Value added (constant 2005 US$) in Belgium in 2010 to that in 2011?
Provide a short and direct response. 0.98. What is the ratio of the Value added (constant 2005 US$) in China in 2010 to that in 2011?
Provide a succinct answer. 0.91. What is the ratio of the Value added (constant 2005 US$) in Mali in 2010 to that in 2011?
Ensure brevity in your answer.  0.96. What is the difference between the highest and the second highest Value added (constant 2005 US$) of Belgium?
Provide a short and direct response. 5.66e+09. What is the difference between the highest and the second highest Value added (constant 2005 US$) in China?
Your answer should be compact. 1.57e+11. What is the difference between the highest and the second highest Value added (constant 2005 US$) in Mali?
Keep it short and to the point. 1.00e+08. What is the difference between the highest and the second highest Value added (constant 2005 US$) in St. Vincent and the Grenadines?
Provide a succinct answer. 4.21e+06. What is the difference between the highest and the lowest Value added (constant 2005 US$) in Belgium?
Your answer should be very brief. 2.06e+1. What is the difference between the highest and the lowest Value added (constant 2005 US$) of China?
Make the answer very short. 7.35e+11. What is the difference between the highest and the lowest Value added (constant 2005 US$) of Mali?
Offer a terse response. 6.18e+08. What is the difference between the highest and the lowest Value added (constant 2005 US$) in St. Vincent and the Grenadines?
Ensure brevity in your answer.  1.12e+07. 